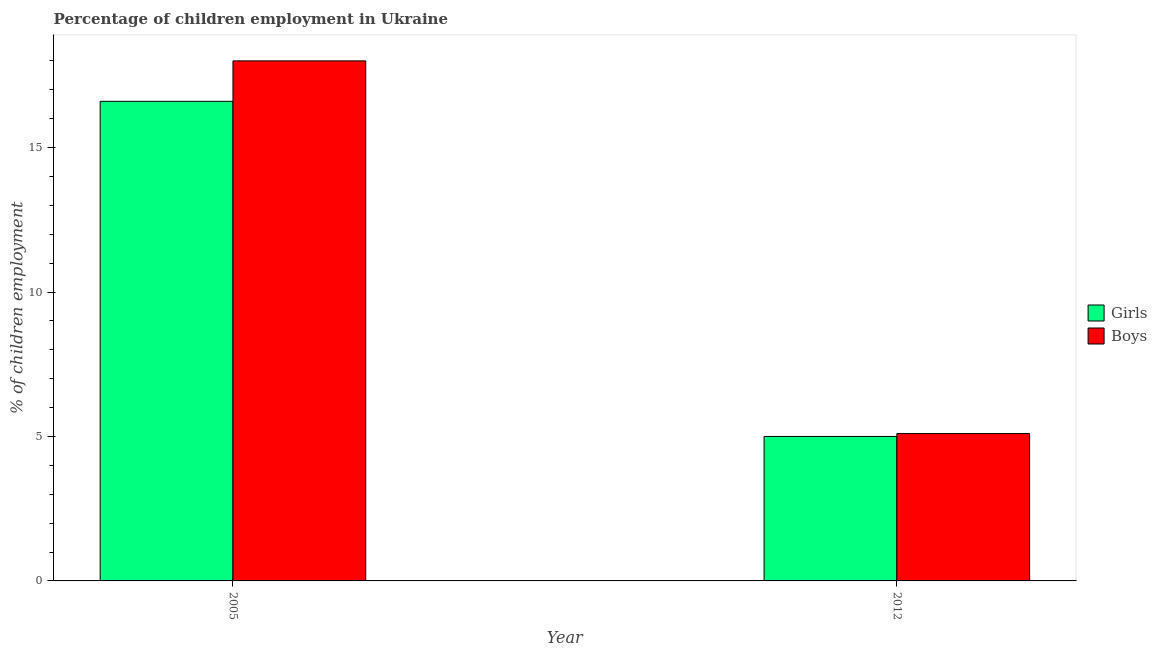How many different coloured bars are there?
Offer a very short reply. 2. Are the number of bars on each tick of the X-axis equal?
Offer a very short reply. Yes. How many bars are there on the 1st tick from the right?
Make the answer very short. 2. What is the percentage of employed girls in 2012?
Your answer should be compact. 5. Across all years, what is the minimum percentage of employed girls?
Offer a terse response. 5. In which year was the percentage of employed boys minimum?
Offer a very short reply. 2012. What is the total percentage of employed boys in the graph?
Your response must be concise. 23.1. What is the difference between the percentage of employed girls in 2005 and the percentage of employed boys in 2012?
Make the answer very short. 11.6. What is the average percentage of employed girls per year?
Provide a succinct answer. 10.8. In the year 2005, what is the difference between the percentage of employed boys and percentage of employed girls?
Provide a short and direct response. 0. What is the ratio of the percentage of employed girls in 2005 to that in 2012?
Make the answer very short. 3.32. In how many years, is the percentage of employed girls greater than the average percentage of employed girls taken over all years?
Keep it short and to the point. 1. What does the 1st bar from the left in 2012 represents?
Give a very brief answer. Girls. What does the 1st bar from the right in 2012 represents?
Make the answer very short. Boys. Are all the bars in the graph horizontal?
Provide a succinct answer. No. How many years are there in the graph?
Offer a terse response. 2. What is the difference between two consecutive major ticks on the Y-axis?
Your response must be concise. 5. Where does the legend appear in the graph?
Give a very brief answer. Center right. How many legend labels are there?
Provide a short and direct response. 2. How are the legend labels stacked?
Keep it short and to the point. Vertical. What is the title of the graph?
Give a very brief answer. Percentage of children employment in Ukraine. Does "Resident" appear as one of the legend labels in the graph?
Offer a very short reply. No. What is the label or title of the Y-axis?
Provide a short and direct response. % of children employment. What is the % of children employment of Girls in 2005?
Your answer should be compact. 16.6. What is the % of children employment in Boys in 2012?
Offer a very short reply. 5.1. Across all years, what is the maximum % of children employment of Girls?
Your response must be concise. 16.6. What is the total % of children employment in Girls in the graph?
Ensure brevity in your answer.  21.6. What is the total % of children employment of Boys in the graph?
Keep it short and to the point. 23.1. What is the difference between the % of children employment in Girls in 2005 and the % of children employment in Boys in 2012?
Keep it short and to the point. 11.5. What is the average % of children employment of Girls per year?
Ensure brevity in your answer.  10.8. What is the average % of children employment of Boys per year?
Ensure brevity in your answer.  11.55. What is the ratio of the % of children employment in Girls in 2005 to that in 2012?
Keep it short and to the point. 3.32. What is the ratio of the % of children employment in Boys in 2005 to that in 2012?
Make the answer very short. 3.53. What is the difference between the highest and the second highest % of children employment of Girls?
Your response must be concise. 11.6. What is the difference between the highest and the second highest % of children employment in Boys?
Offer a terse response. 12.9. What is the difference between the highest and the lowest % of children employment in Girls?
Your response must be concise. 11.6. What is the difference between the highest and the lowest % of children employment of Boys?
Your answer should be compact. 12.9. 